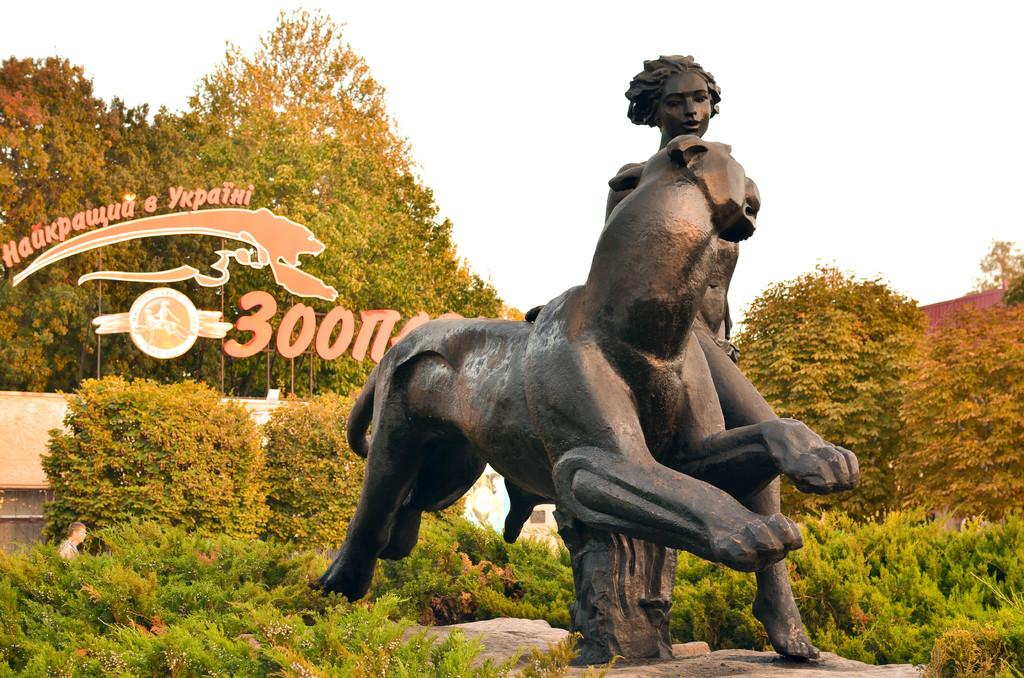What is the main subject in the image? There is a statue in the image. What else can be seen in the image besides the statue? There is text with a logo, trees, plants, a person in the background, and the sky visible in the image. Can you describe the natural elements in the image? Trees and plants are present in the image. What is the condition of the sky in the image? The sky is visible in the image. What type of amusement can be seen in the wilderness in the image? There is no amusement or wilderness present in the image; it features a statue, text with a logo, trees, plants, a person in the background, and the sky. Can you tell me how many firemen are visible in the image? There are no firemen present in the image. 